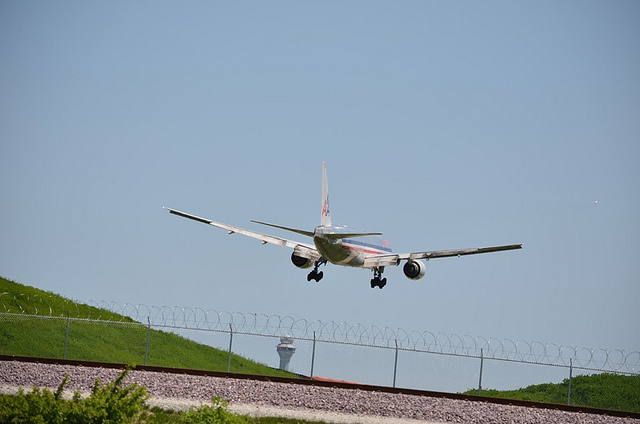Describe the objects in this image and their specific colors. I can see a airplane in gray, black, darkgray, and lightgray tones in this image. 